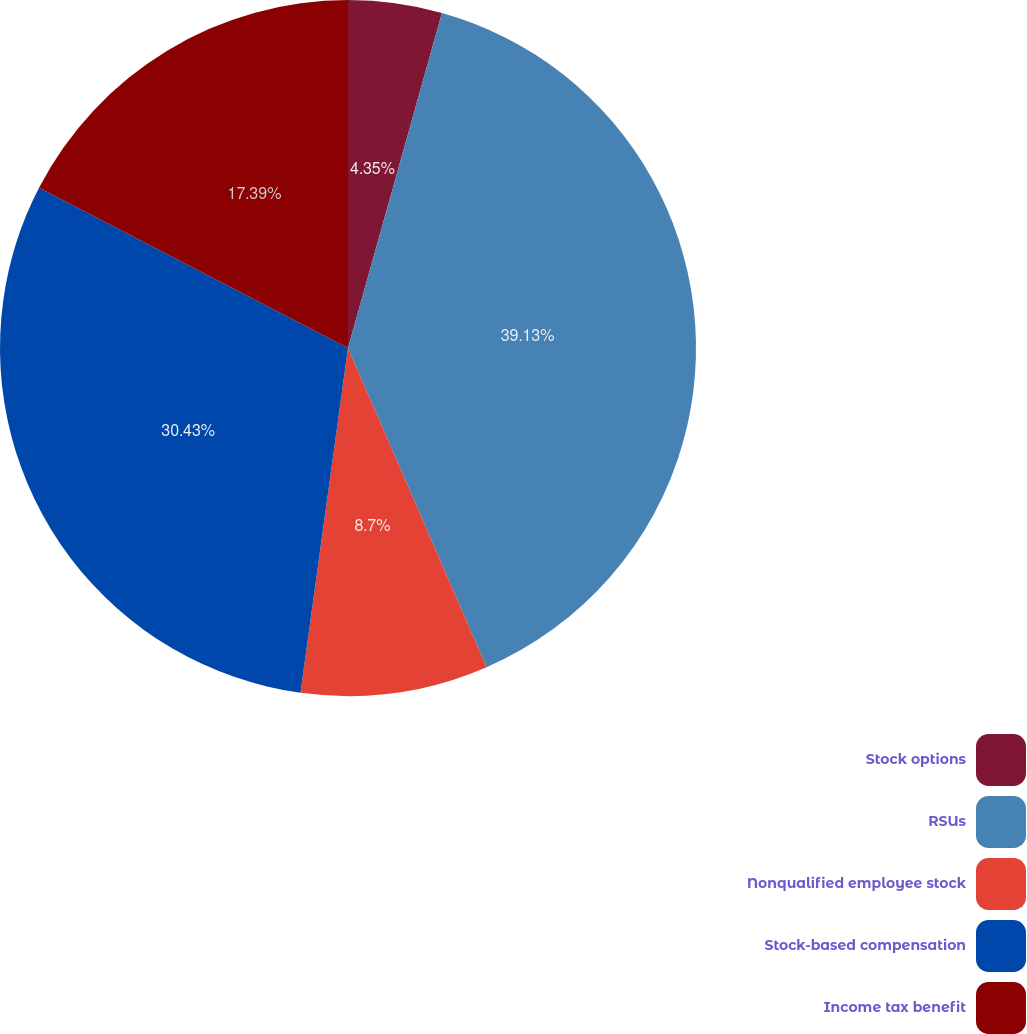<chart> <loc_0><loc_0><loc_500><loc_500><pie_chart><fcel>Stock options<fcel>RSUs<fcel>Nonqualified employee stock<fcel>Stock-based compensation<fcel>Income tax benefit<nl><fcel>4.35%<fcel>39.13%<fcel>8.7%<fcel>30.43%<fcel>17.39%<nl></chart> 